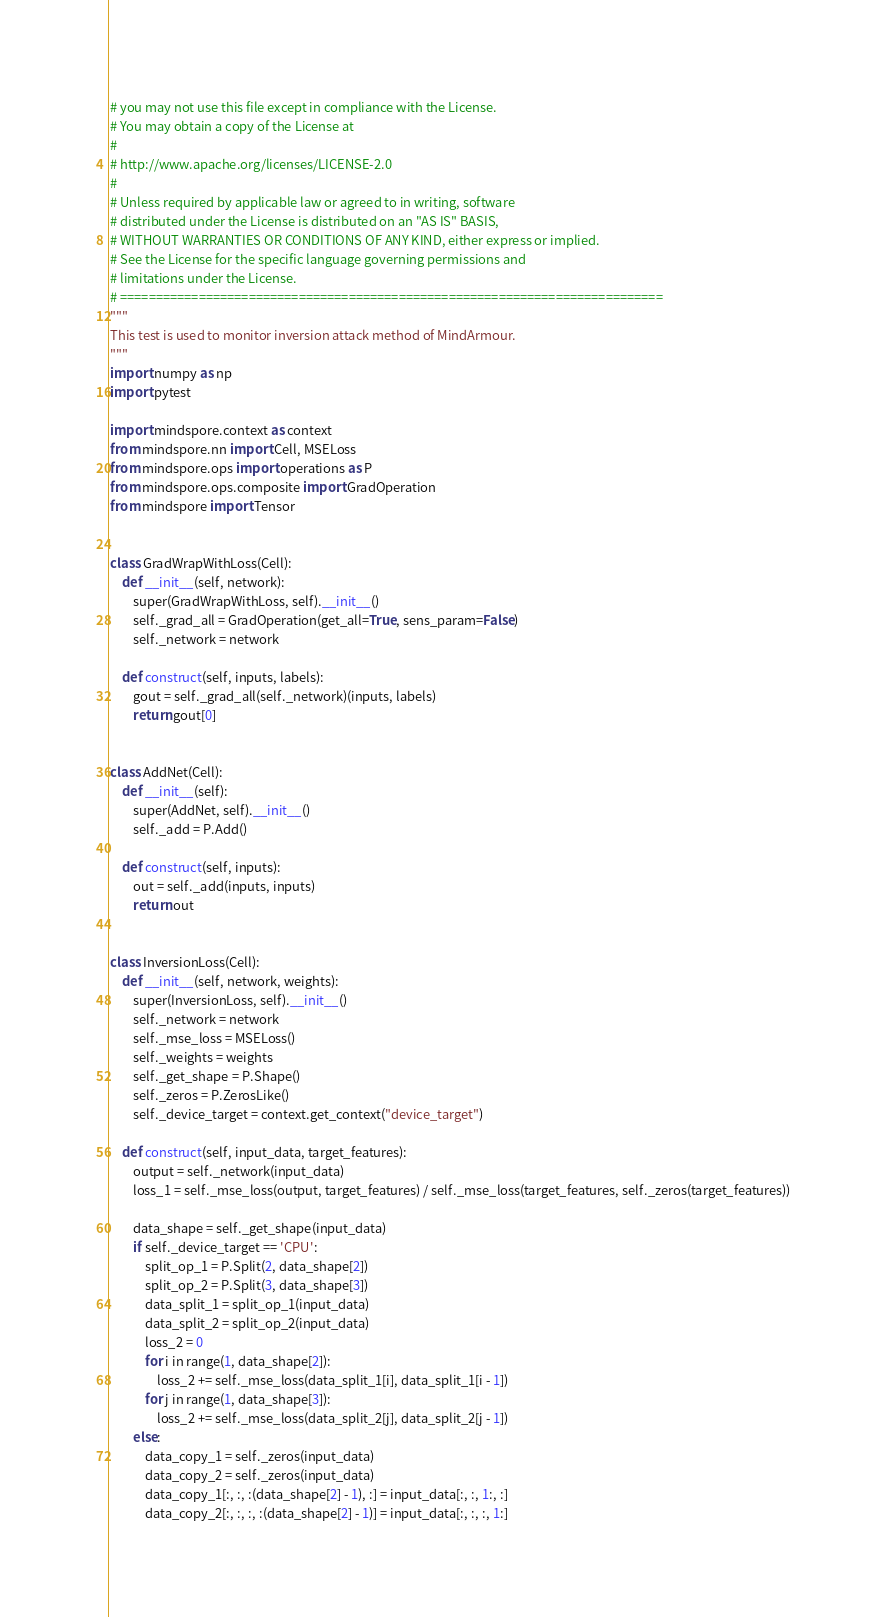Convert code to text. <code><loc_0><loc_0><loc_500><loc_500><_Python_># you may not use this file except in compliance with the License.
# You may obtain a copy of the License at
#
# http://www.apache.org/licenses/LICENSE-2.0
#
# Unless required by applicable law or agreed to in writing, software
# distributed under the License is distributed on an "AS IS" BASIS,
# WITHOUT WARRANTIES OR CONDITIONS OF ANY KIND, either express or implied.
# See the License for the specific language governing permissions and
# limitations under the License.
# ============================================================================
"""
This test is used to monitor inversion attack method of MindArmour.
"""
import numpy as np
import pytest

import mindspore.context as context
from mindspore.nn import Cell, MSELoss
from mindspore.ops import operations as P
from mindspore.ops.composite import GradOperation
from mindspore import Tensor


class GradWrapWithLoss(Cell):
    def __init__(self, network):
        super(GradWrapWithLoss, self).__init__()
        self._grad_all = GradOperation(get_all=True, sens_param=False)
        self._network = network

    def construct(self, inputs, labels):
        gout = self._grad_all(self._network)(inputs, labels)
        return gout[0]


class AddNet(Cell):
    def __init__(self):
        super(AddNet, self).__init__()
        self._add = P.Add()

    def construct(self, inputs):
        out = self._add(inputs, inputs)
        return out


class InversionLoss(Cell):
    def __init__(self, network, weights):
        super(InversionLoss, self).__init__()
        self._network = network
        self._mse_loss = MSELoss()
        self._weights = weights
        self._get_shape = P.Shape()
        self._zeros = P.ZerosLike()
        self._device_target = context.get_context("device_target")

    def construct(self, input_data, target_features):
        output = self._network(input_data)
        loss_1 = self._mse_loss(output, target_features) / self._mse_loss(target_features, self._zeros(target_features))

        data_shape = self._get_shape(input_data)
        if self._device_target == 'CPU':
            split_op_1 = P.Split(2, data_shape[2])
            split_op_2 = P.Split(3, data_shape[3])
            data_split_1 = split_op_1(input_data)
            data_split_2 = split_op_2(input_data)
            loss_2 = 0
            for i in range(1, data_shape[2]):
                loss_2 += self._mse_loss(data_split_1[i], data_split_1[i - 1])
            for j in range(1, data_shape[3]):
                loss_2 += self._mse_loss(data_split_2[j], data_split_2[j - 1])
        else:
            data_copy_1 = self._zeros(input_data)
            data_copy_2 = self._zeros(input_data)
            data_copy_1[:, :, :(data_shape[2] - 1), :] = input_data[:, :, 1:, :]
            data_copy_2[:, :, :, :(data_shape[2] - 1)] = input_data[:, :, :, 1:]</code> 